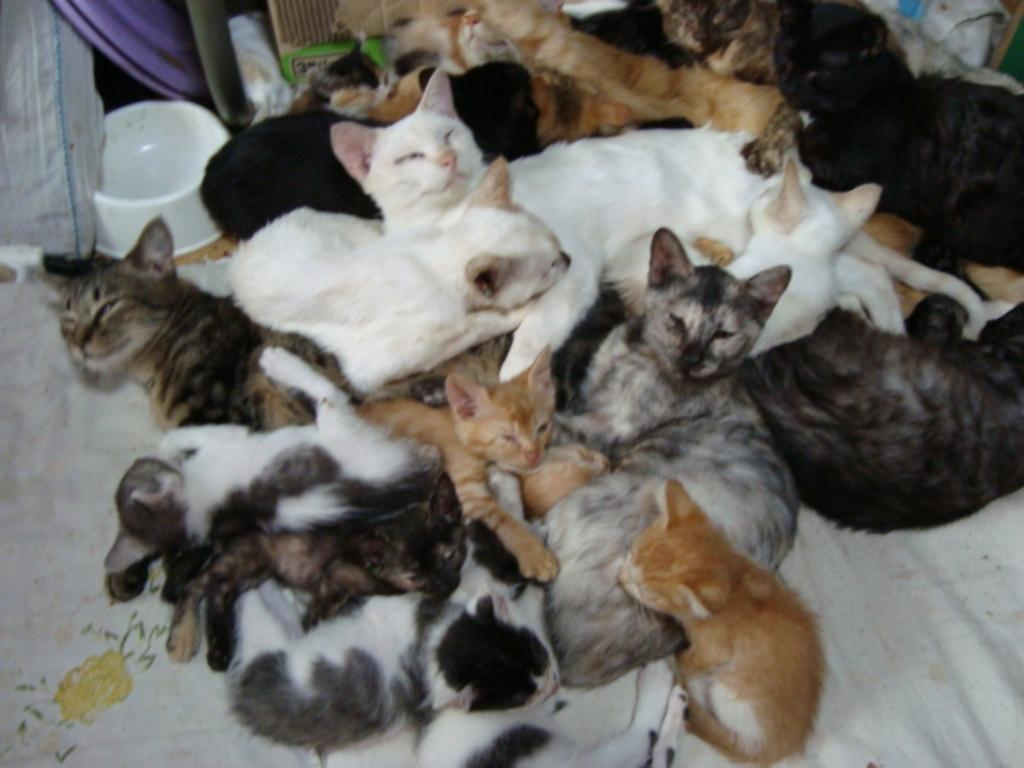What type of animals are in the image? There is a group of cats in the image. Where are the cats located? The cats are on a cloth. What else can be seen in the image besides the cats? There is a bowl in the image. What can be seen in the background of the image? There are objects visible in the background of the image. What color is the hydrant in the image? There is no hydrant present in the image. How many oranges are on the cloth with the cats? There are no oranges visible in the image. 